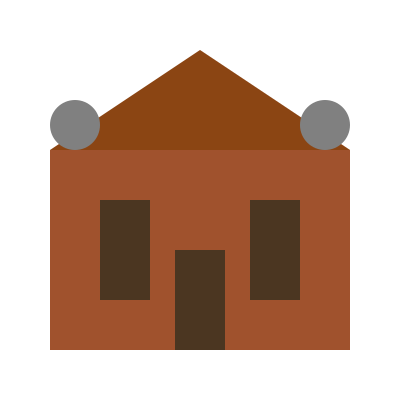As a military expert with knowledge of medieval fortifications, analyze the 3D model of this simplified castle. How many distinct faces of the structure are visible from this perspective, considering the main keep, towers, and entrance? To determine the number of visible faces, let's break down the castle structure:

1. Main keep (central structure):
   - Front face: 1
   - Roof (visible sloped surface): 1

2. Towers:
   - Two circular tower tops: 2
   - Front faces of towers (partially visible): 2

3. Entrance:
   - Front face of the entrance: 1

4. Side walls:
   - Though not fully visible, we can discern the edges of the side walls: 2

The total count of visible faces is the sum of all these components:

$1 + 1 + 2 + 2 + 1 + 2 = 9$

It's important to note that in actual medieval castle designs, there would be more complex architectural features. However, this simplified model focuses on the primary elements to test spatial intelligence in recognizing distinct surfaces from a single viewpoint.
Answer: 9 faces 